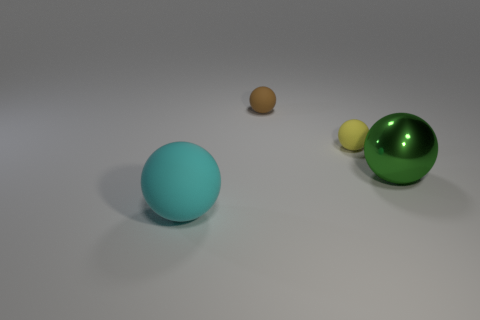There is a thing in front of the large metallic sphere; is its size the same as the rubber ball behind the yellow rubber ball?
Your answer should be very brief. No. How many objects are small things or large cyan spheres?
Offer a very short reply. 3. What shape is the big green metallic object?
Ensure brevity in your answer.  Sphere. What size is the brown thing that is the same shape as the yellow thing?
Offer a very short reply. Small. Is there anything else that is made of the same material as the cyan ball?
Your answer should be very brief. Yes. What size is the rubber ball behind the tiny matte ball that is in front of the brown rubber thing?
Provide a succinct answer. Small. Are there an equal number of large green metal objects that are behind the small brown ball and large matte cylinders?
Your answer should be very brief. Yes. How many other objects are there of the same color as the metallic sphere?
Ensure brevity in your answer.  0. Is the number of matte spheres on the left side of the small yellow matte sphere less than the number of tiny red metal objects?
Make the answer very short. No. Is there another yellow sphere of the same size as the yellow matte sphere?
Provide a succinct answer. No. 